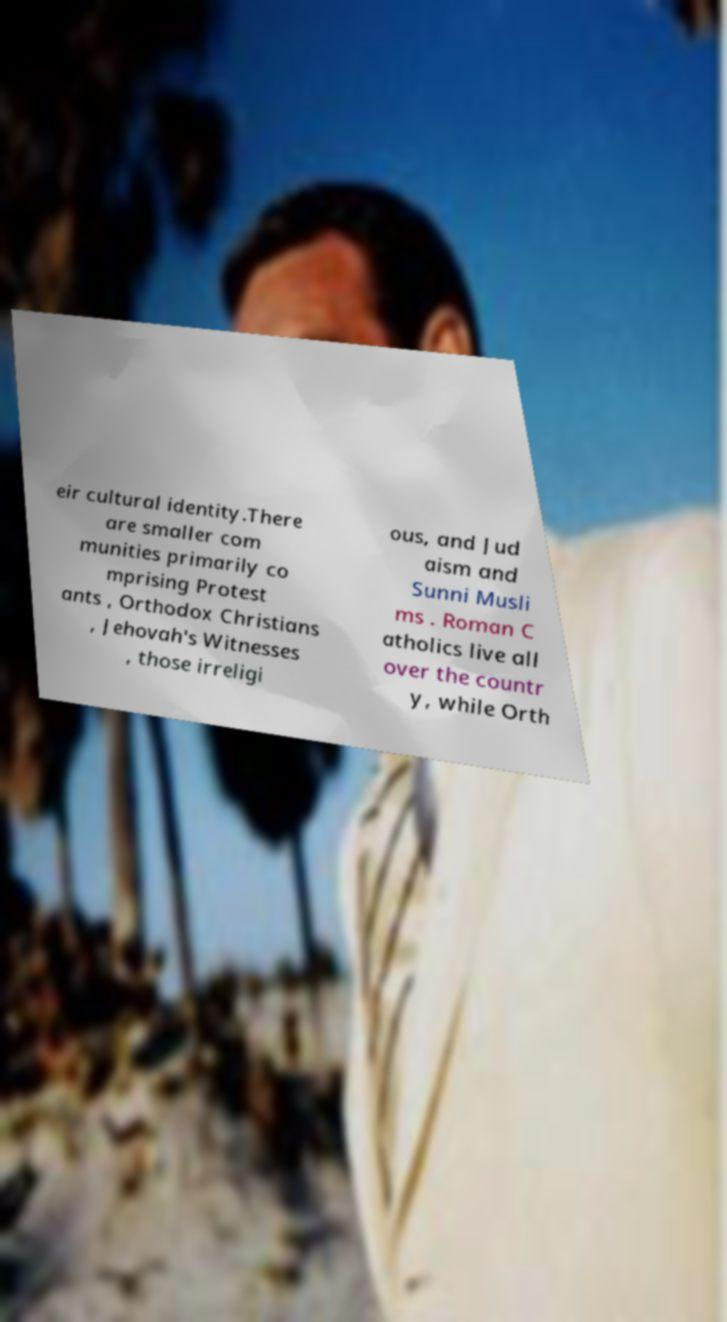Can you read and provide the text displayed in the image?This photo seems to have some interesting text. Can you extract and type it out for me? eir cultural identity.There are smaller com munities primarily co mprising Protest ants , Orthodox Christians , Jehovah's Witnesses , those irreligi ous, and Jud aism and Sunni Musli ms . Roman C atholics live all over the countr y, while Orth 